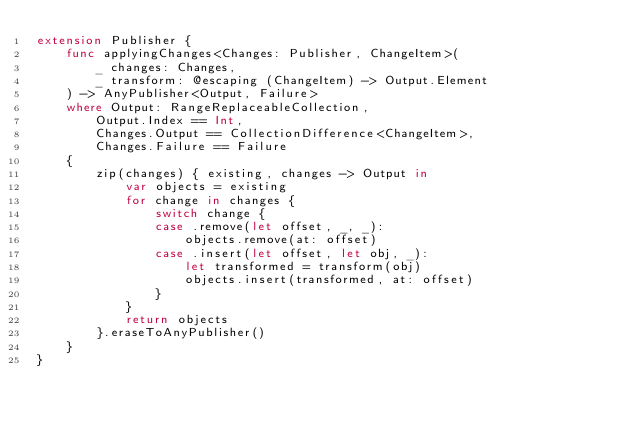<code> <loc_0><loc_0><loc_500><loc_500><_Swift_>extension Publisher {
    func applyingChanges<Changes: Publisher, ChangeItem>(
        _ changes: Changes,
        _ transform: @escaping (ChangeItem) -> Output.Element
    ) -> AnyPublisher<Output, Failure>
    where Output: RangeReplaceableCollection,
        Output.Index == Int,
        Changes.Output == CollectionDifference<ChangeItem>,
        Changes.Failure == Failure
    {
        zip(changes) { existing, changes -> Output in
            var objects = existing
            for change in changes {
                switch change {
                case .remove(let offset, _, _):
                    objects.remove(at: offset)
                case .insert(let offset, let obj, _):
                    let transformed = transform(obj)
                    objects.insert(transformed, at: offset)
                }
            }
            return objects
        }.eraseToAnyPublisher()
    }
}</code> 